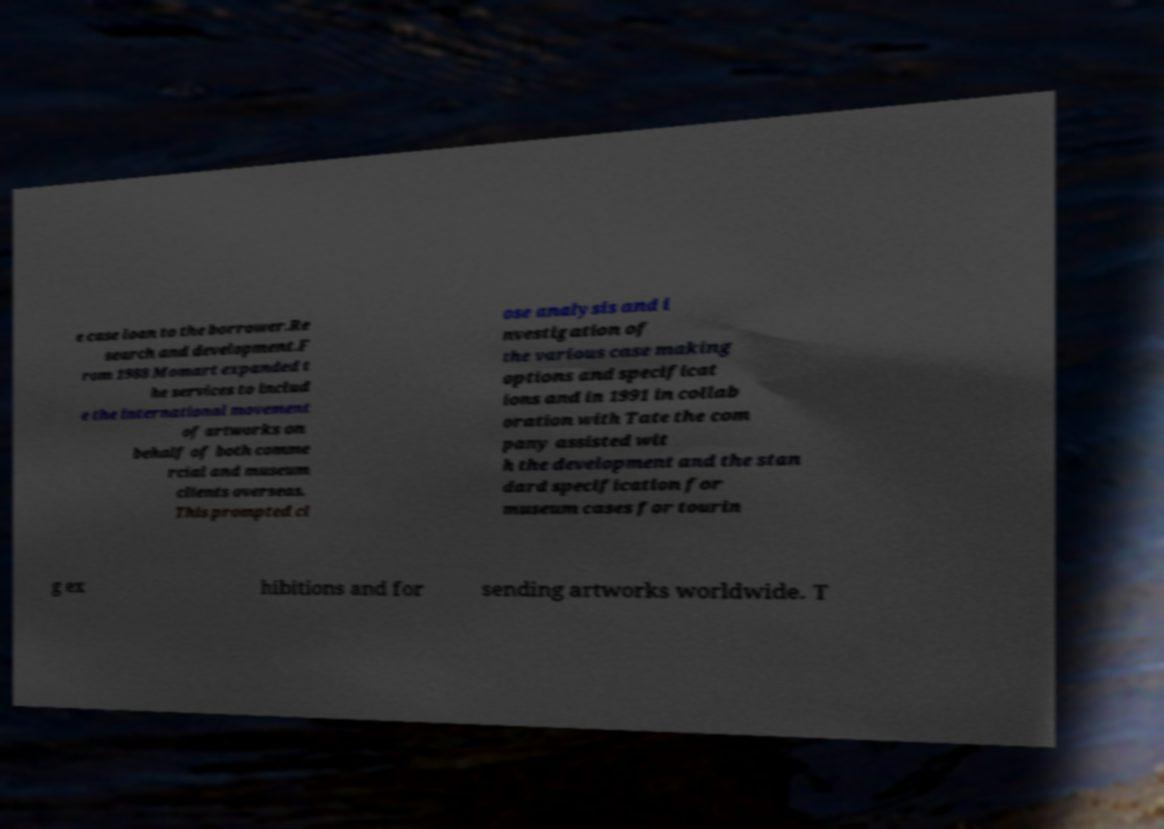Could you assist in decoding the text presented in this image and type it out clearly? e case loan to the borrower.Re search and development.F rom 1988 Momart expanded t he services to includ e the international movement of artworks on behalf of both comme rcial and museum clients overseas. This prompted cl ose analysis and i nvestigation of the various case making options and specificat ions and in 1991 in collab oration with Tate the com pany assisted wit h the development and the stan dard specification for museum cases for tourin g ex hibitions and for sending artworks worldwide. T 